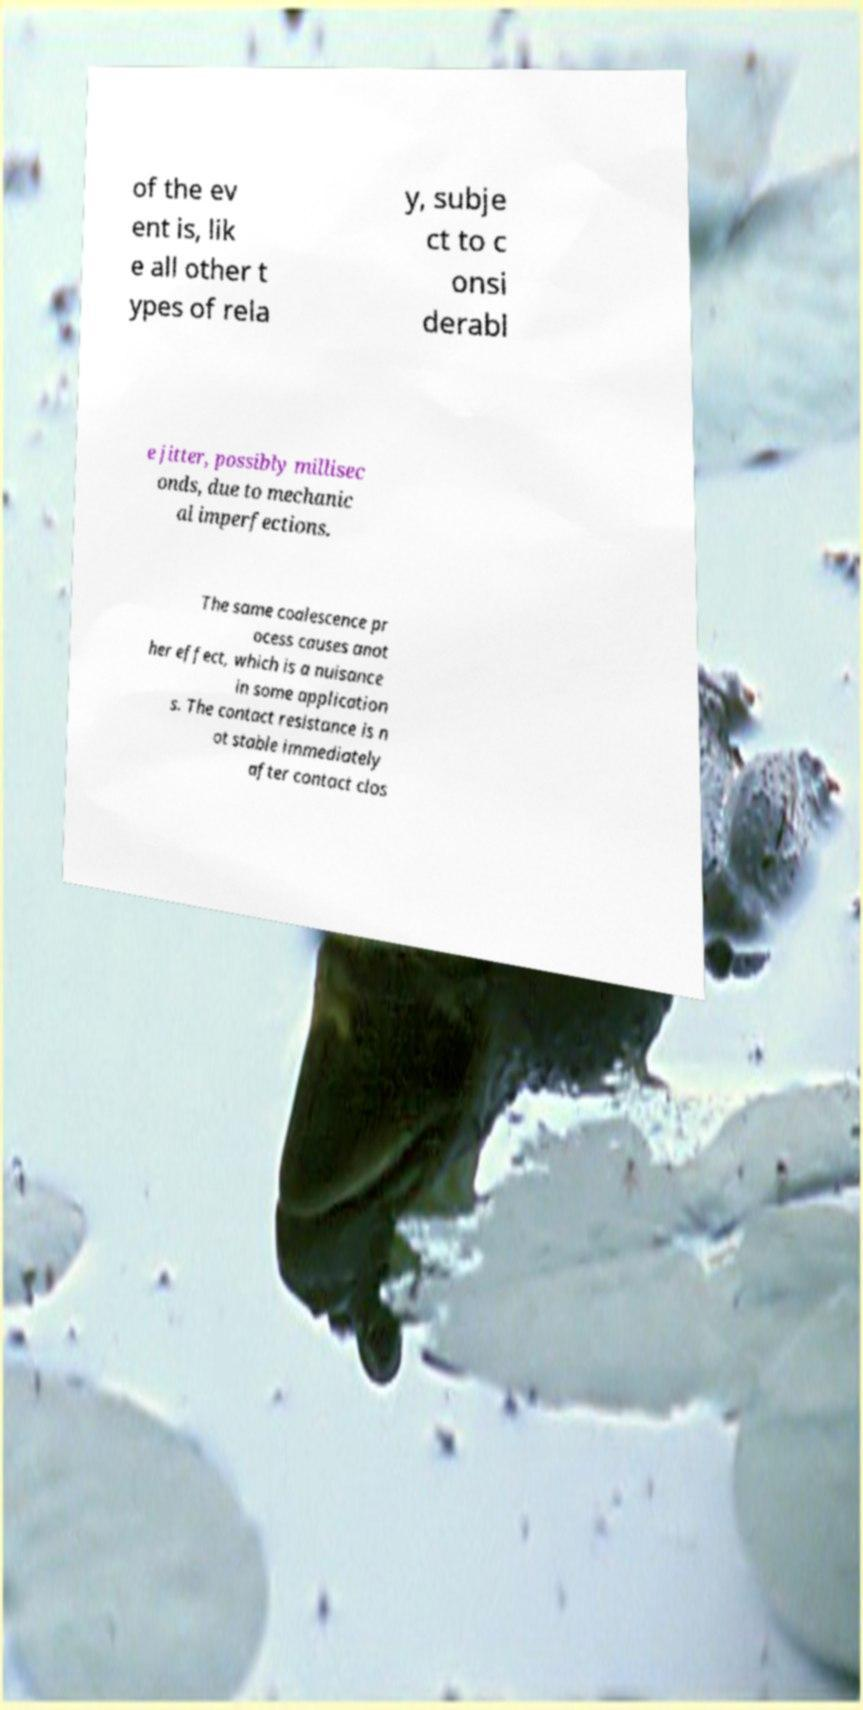What messages or text are displayed in this image? I need them in a readable, typed format. of the ev ent is, lik e all other t ypes of rela y, subje ct to c onsi derabl e jitter, possibly millisec onds, due to mechanic al imperfections. The same coalescence pr ocess causes anot her effect, which is a nuisance in some application s. The contact resistance is n ot stable immediately after contact clos 